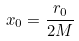<formula> <loc_0><loc_0><loc_500><loc_500>x _ { 0 } = \frac { r _ { 0 } } { 2 M }</formula> 